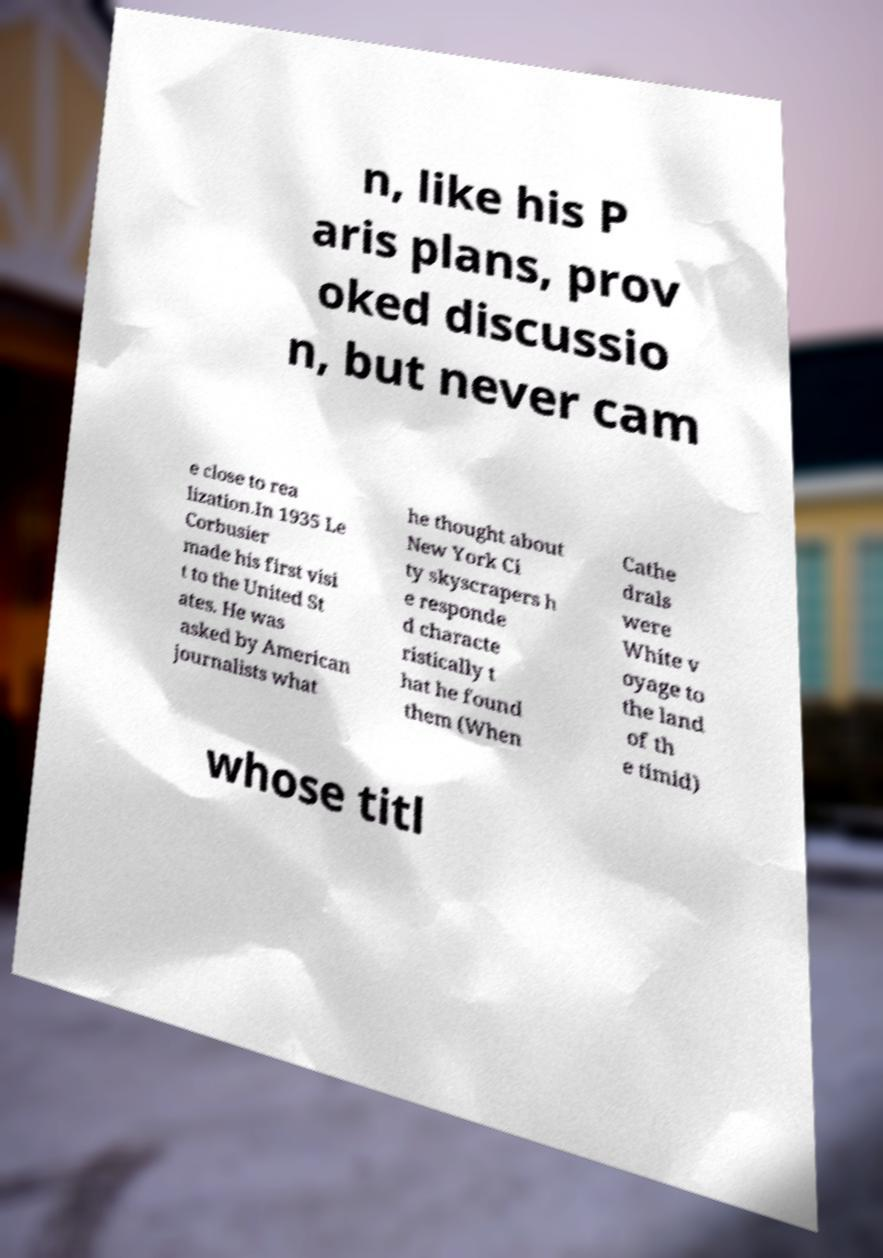What messages or text are displayed in this image? I need them in a readable, typed format. n, like his P aris plans, prov oked discussio n, but never cam e close to rea lization.In 1935 Le Corbusier made his first visi t to the United St ates. He was asked by American journalists what he thought about New York Ci ty skyscrapers h e responde d characte ristically t hat he found them (When Cathe drals were White v oyage to the land of th e timid) whose titl 